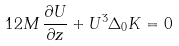<formula> <loc_0><loc_0><loc_500><loc_500>1 2 M \, \frac { \partial U } { \partial z } + U ^ { 3 } \Delta _ { 0 } K = 0</formula> 